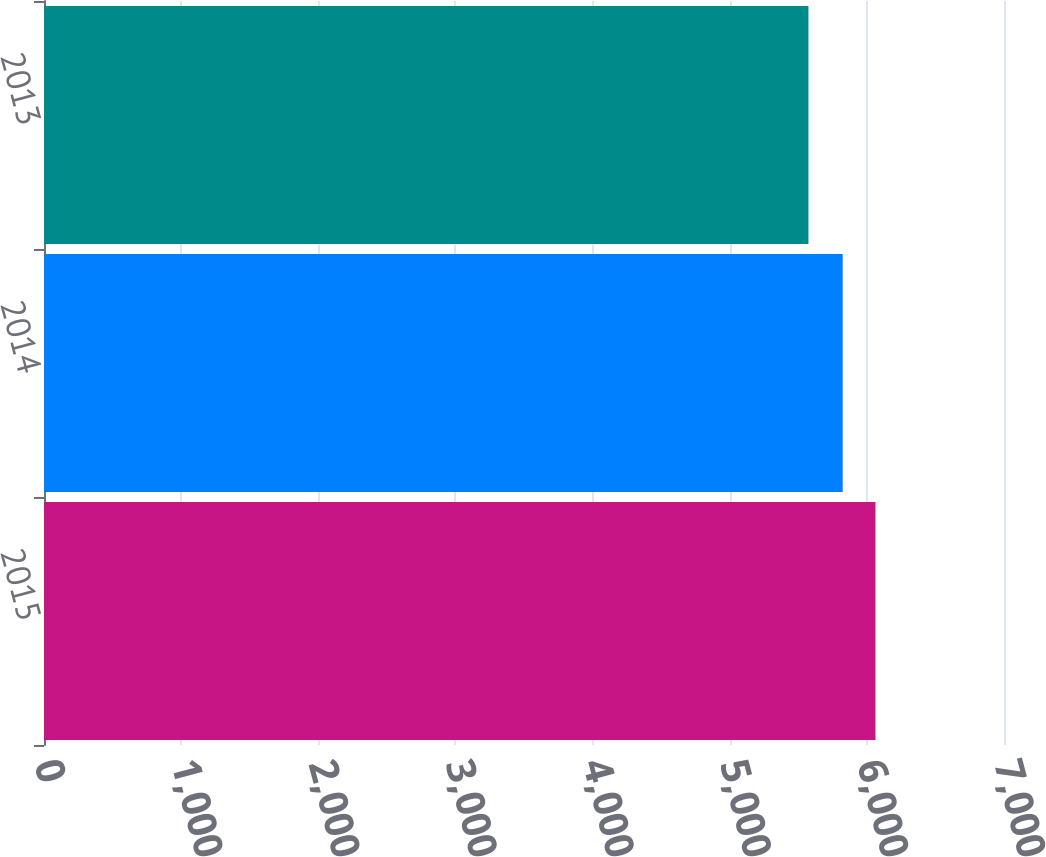Convert chart. <chart><loc_0><loc_0><loc_500><loc_500><bar_chart><fcel>2015<fcel>2014<fcel>2013<nl><fcel>6063<fcel>5824<fcel>5574<nl></chart> 